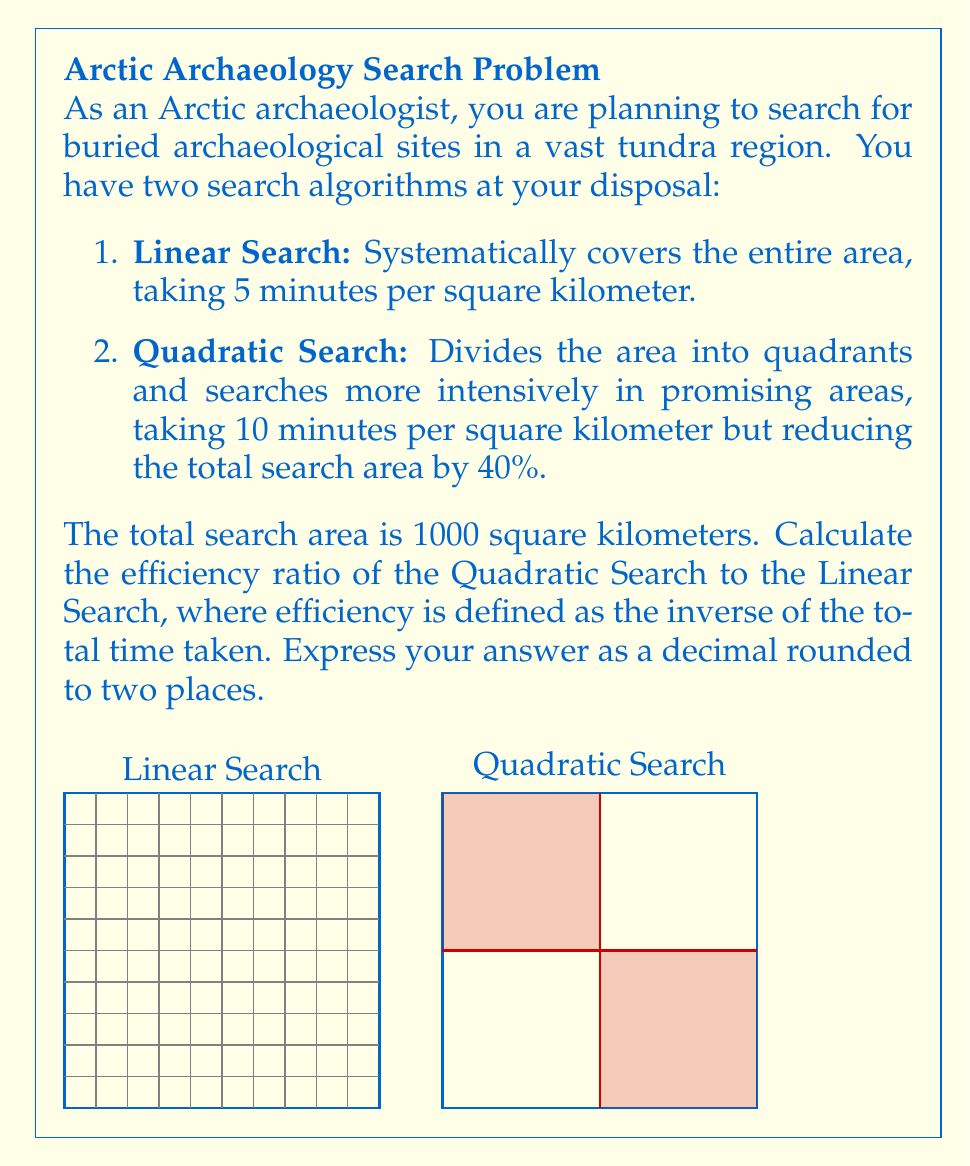What is the answer to this math problem? Let's approach this step-by-step:

1) First, calculate the time for Linear Search:
   $$T_{linear} = 1000 \text{ km}^2 \times 5 \text{ min/km}^2 = 5000 \text{ minutes}$$

2) For Quadratic Search, we need to consider the reduced search area:
   $$\text{Reduced area} = 1000 \text{ km}^2 \times (1 - 0.40) = 600 \text{ km}^2$$

3) Now calculate the time for Quadratic Search:
   $$T_{quadratic} = 600 \text{ km}^2 \times 10 \text{ min/km}^2 = 6000 \text{ minutes}$$

4) Efficiency is defined as the inverse of time taken. Let's calculate efficiencies:
   $$E_{linear} = \frac{1}{T_{linear}} = \frac{1}{5000}$$
   $$E_{quadratic} = \frac{1}{T_{quadratic}} = \frac{1}{6000}$$

5) The efficiency ratio is:
   $$\text{Efficiency Ratio} = \frac{E_{quadratic}}{E_{linear}} = \frac{5000}{6000} = \frac{5}{6} \approx 0.8333$$

6) Rounding to two decimal places:
   $$\text{Efficiency Ratio} \approx 0.83$$
Answer: 0.83 